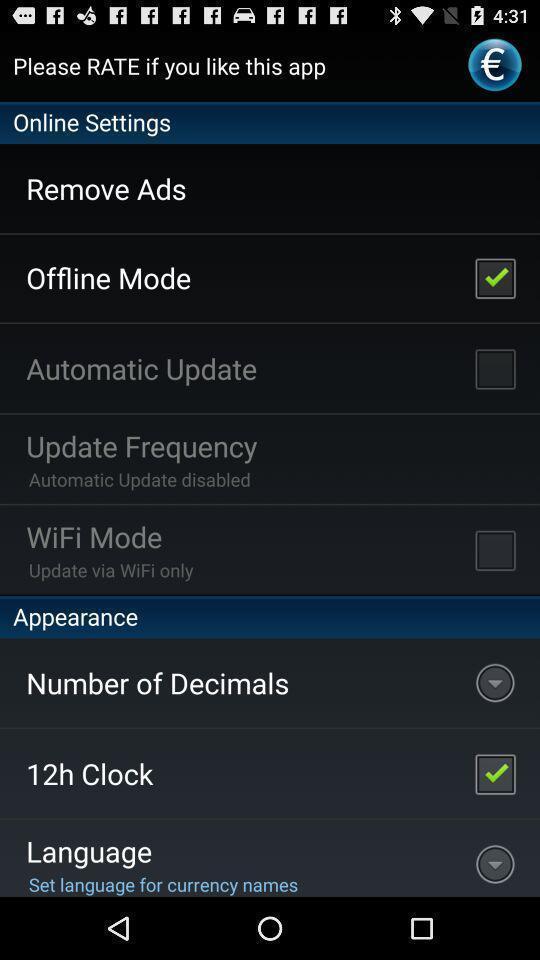Summarize the main components in this picture. Settings page of currency convertor application. 